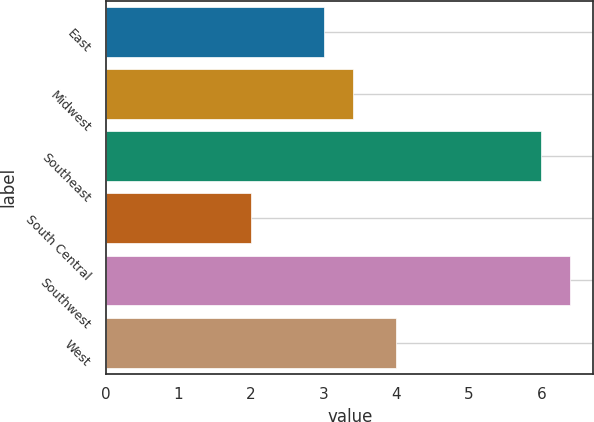Convert chart. <chart><loc_0><loc_0><loc_500><loc_500><bar_chart><fcel>East<fcel>Midwest<fcel>Southeast<fcel>South Central<fcel>Southwest<fcel>West<nl><fcel>3<fcel>3.4<fcel>6<fcel>2<fcel>6.4<fcel>4<nl></chart> 